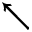Convert formula to latex. <formula><loc_0><loc_0><loc_500><loc_500>\nwarrow</formula> 